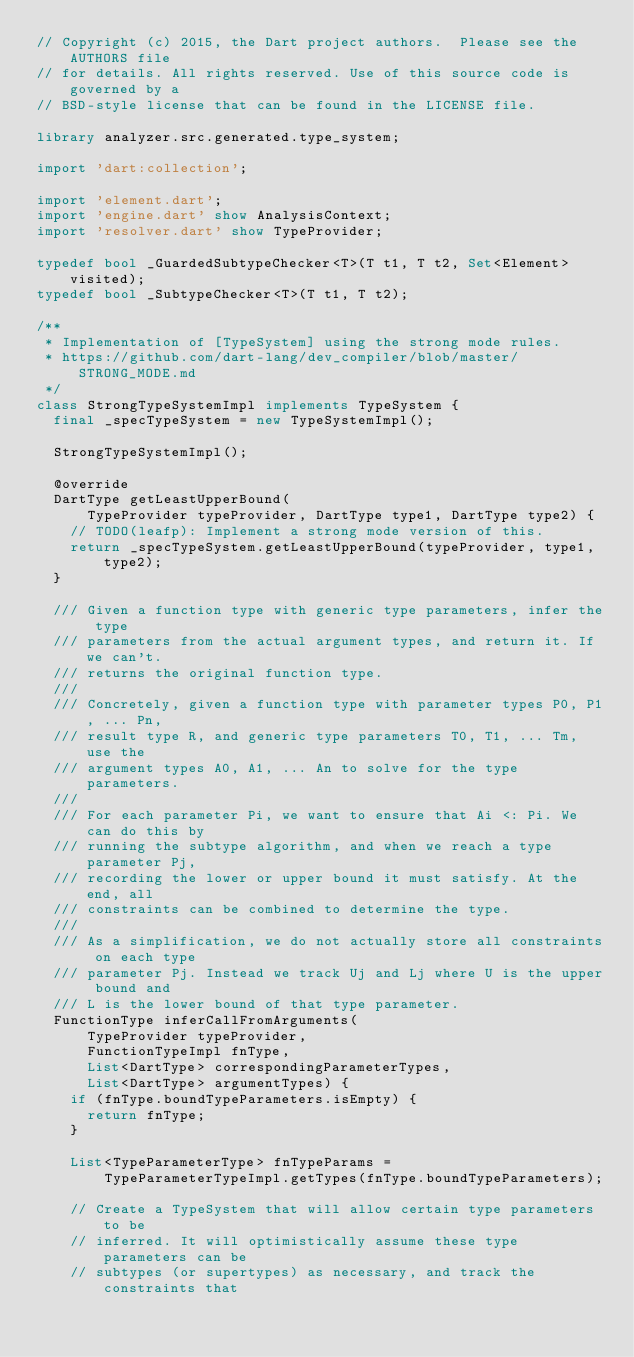<code> <loc_0><loc_0><loc_500><loc_500><_Dart_>// Copyright (c) 2015, the Dart project authors.  Please see the AUTHORS file
// for details. All rights reserved. Use of this source code is governed by a
// BSD-style license that can be found in the LICENSE file.

library analyzer.src.generated.type_system;

import 'dart:collection';

import 'element.dart';
import 'engine.dart' show AnalysisContext;
import 'resolver.dart' show TypeProvider;

typedef bool _GuardedSubtypeChecker<T>(T t1, T t2, Set<Element> visited);
typedef bool _SubtypeChecker<T>(T t1, T t2);

/**
 * Implementation of [TypeSystem] using the strong mode rules.
 * https://github.com/dart-lang/dev_compiler/blob/master/STRONG_MODE.md
 */
class StrongTypeSystemImpl implements TypeSystem {
  final _specTypeSystem = new TypeSystemImpl();

  StrongTypeSystemImpl();

  @override
  DartType getLeastUpperBound(
      TypeProvider typeProvider, DartType type1, DartType type2) {
    // TODO(leafp): Implement a strong mode version of this.
    return _specTypeSystem.getLeastUpperBound(typeProvider, type1, type2);
  }

  /// Given a function type with generic type parameters, infer the type
  /// parameters from the actual argument types, and return it. If we can't.
  /// returns the original function type.
  ///
  /// Concretely, given a function type with parameter types P0, P1, ... Pn,
  /// result type R, and generic type parameters T0, T1, ... Tm, use the
  /// argument types A0, A1, ... An to solve for the type parameters.
  ///
  /// For each parameter Pi, we want to ensure that Ai <: Pi. We can do this by
  /// running the subtype algorithm, and when we reach a type parameter Pj,
  /// recording the lower or upper bound it must satisfy. At the end, all
  /// constraints can be combined to determine the type.
  ///
  /// As a simplification, we do not actually store all constraints on each type
  /// parameter Pj. Instead we track Uj and Lj where U is the upper bound and
  /// L is the lower bound of that type parameter.
  FunctionType inferCallFromArguments(
      TypeProvider typeProvider,
      FunctionTypeImpl fnType,
      List<DartType> correspondingParameterTypes,
      List<DartType> argumentTypes) {
    if (fnType.boundTypeParameters.isEmpty) {
      return fnType;
    }

    List<TypeParameterType> fnTypeParams =
        TypeParameterTypeImpl.getTypes(fnType.boundTypeParameters);

    // Create a TypeSystem that will allow certain type parameters to be
    // inferred. It will optimistically assume these type parameters can be
    // subtypes (or supertypes) as necessary, and track the constraints that</code> 